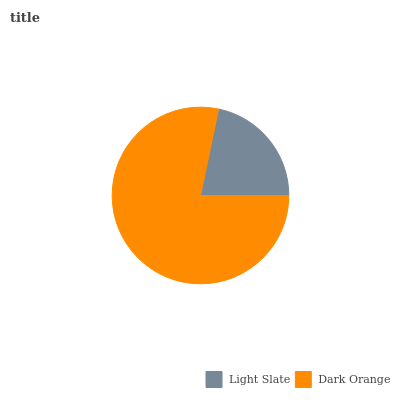Is Light Slate the minimum?
Answer yes or no. Yes. Is Dark Orange the maximum?
Answer yes or no. Yes. Is Dark Orange the minimum?
Answer yes or no. No. Is Dark Orange greater than Light Slate?
Answer yes or no. Yes. Is Light Slate less than Dark Orange?
Answer yes or no. Yes. Is Light Slate greater than Dark Orange?
Answer yes or no. No. Is Dark Orange less than Light Slate?
Answer yes or no. No. Is Dark Orange the high median?
Answer yes or no. Yes. Is Light Slate the low median?
Answer yes or no. Yes. Is Light Slate the high median?
Answer yes or no. No. Is Dark Orange the low median?
Answer yes or no. No. 